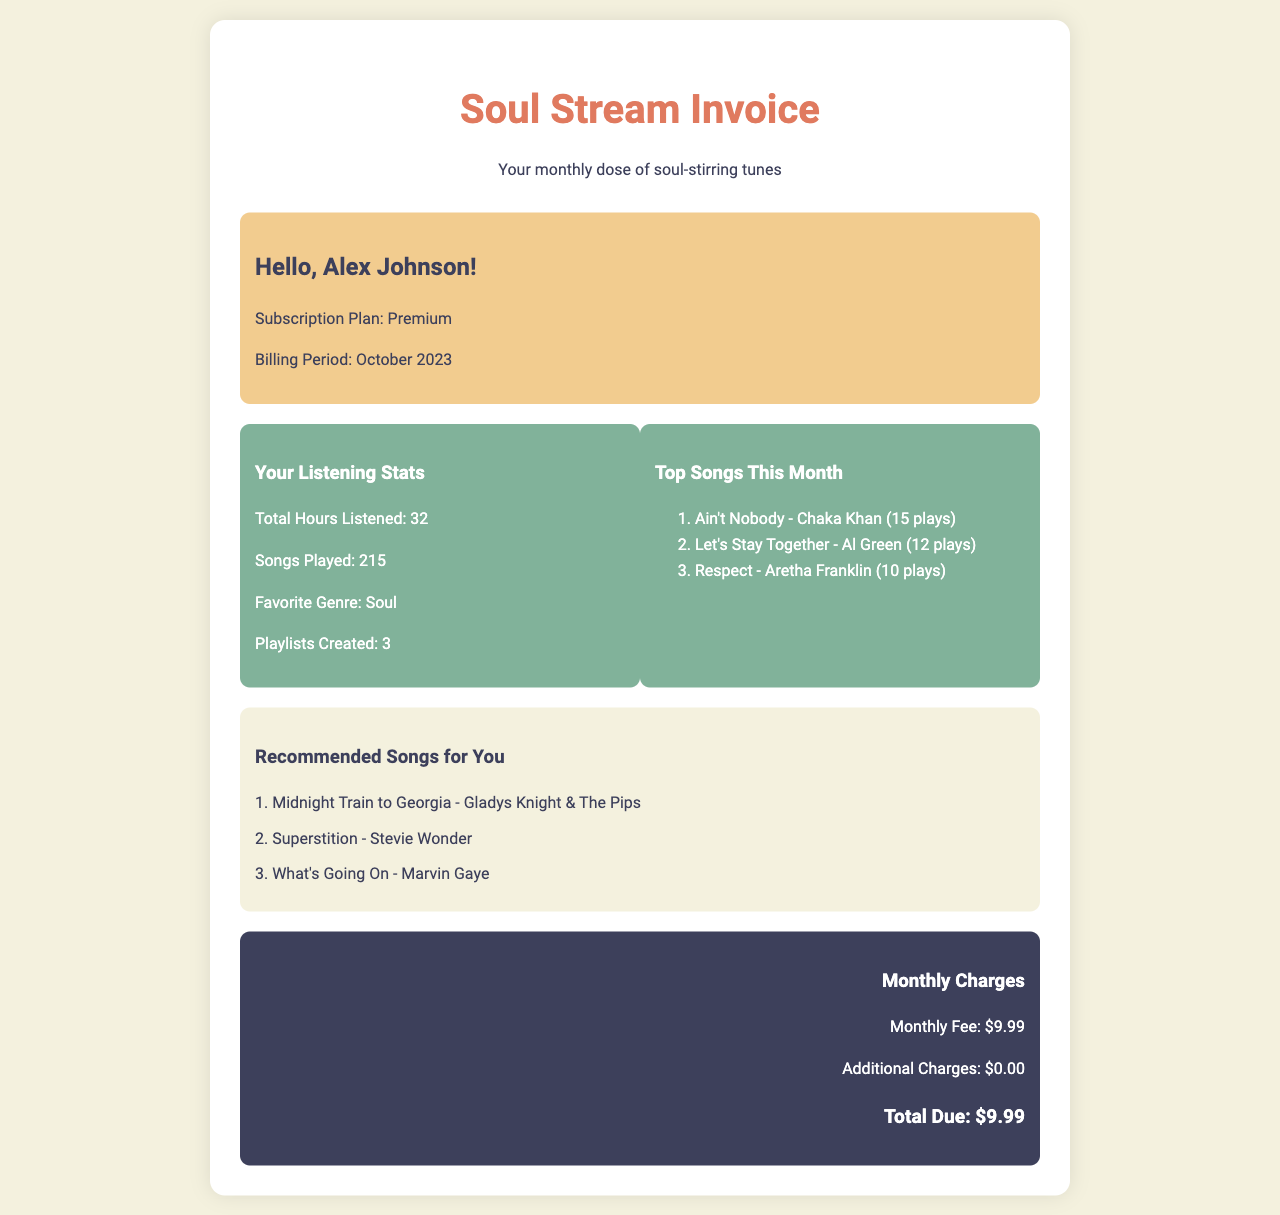What is the subscription plan? The subscription plan is mentioned in the user info section of the document.
Answer: Premium How many total hours were listened? The document states the total hours listened in the listening stats section.
Answer: 32 What are the top songs this month? The document provides a list of top songs played in the stats box section.
Answer: Ain't Nobody - Chaka Khan, Let's Stay Together - Al Green, Respect - Aretha Franklin What is the billing period? The billing period is specified in the user info section.
Answer: October 2023 What is the total due amount? The total due amount is listed under the monthly charges section of the document.
Answer: $9.99 Which genre is favored most? The favorite genre is noted in the listening stats section.
Answer: Soul How many playlists were created? The number of playlists created is found in the stats box under listening stats.
Answer: 3 What is one recommended song? The recommended songs are listed in the song list section.
Answer: Midnight Train to Georgia - Gladys Knight & The Pips What is the monthly fee? The monthly fee is detailed in the charges section of the document.
Answer: $9.99 